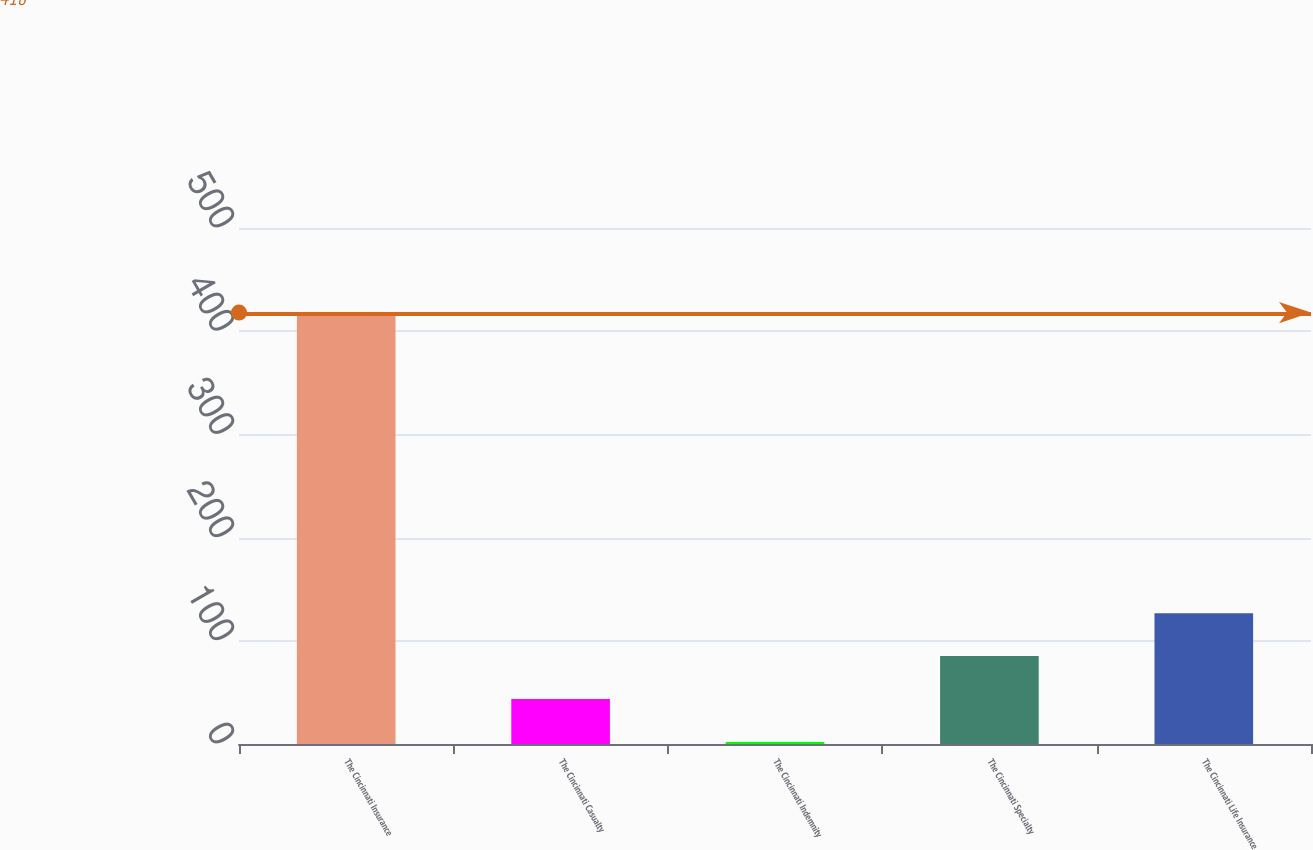Convert chart. <chart><loc_0><loc_0><loc_500><loc_500><bar_chart><fcel>The Cincinnati Insurance<fcel>The Cincinnati Casualty<fcel>The Cincinnati Indemnity<fcel>The Cincinnati Specialty<fcel>The Cincinnati Life Insurance<nl><fcel>418<fcel>43.6<fcel>2<fcel>85.2<fcel>126.8<nl></chart> 